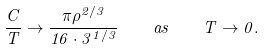<formula> <loc_0><loc_0><loc_500><loc_500>\frac { C } { T } \rightarrow \frac { \pi \rho ^ { 2 / 3 } } { 1 6 \cdot 3 ^ { 1 / 3 } } \quad a s \quad T \rightarrow 0 .</formula> 